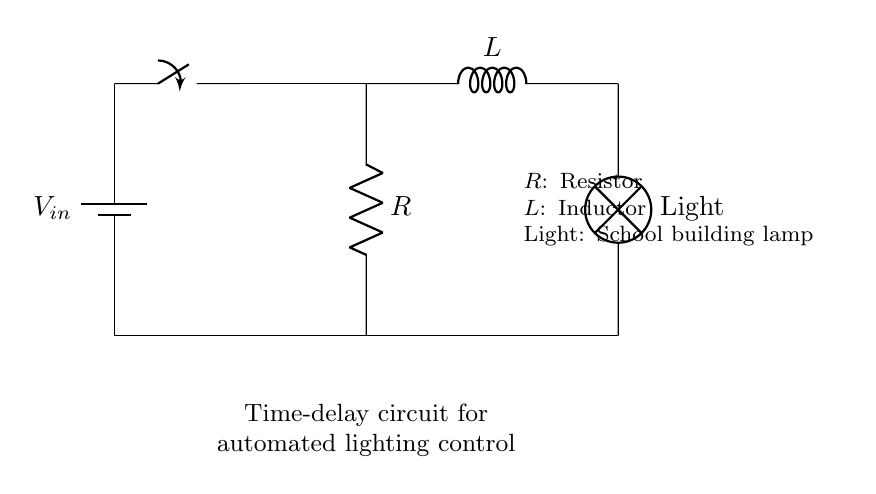What is the primary function of this circuit? The primary function of this circuit is to control the lighting automatically, by implementing a time delay before the light is turned on. This can be inferred from the circuit's designation as a time-delay circuit for automated lighting control.
Answer: Automated lighting control What are the main components used in this circuit? The main components used in this circuit are a resistor, an inductor, a light (lamp), a switch, and a battery. These components are visually identifiable in the circuit diagram.
Answer: Resistor, inductor, lamp, switch, battery What is the role of the inductor in this circuit? The inductor in this circuit helps create a delay in current flow to the lamp when the switch is closed. Because inductors resist changes in current, they store energy in the magnetic field, allowing the light to turn on after a delay instead of instantly.
Answer: Current delay How does the resistor affect the circuit's performance? The resistor limits the amount of current flowing through the circuit, which helps protect the components and can also affect the timing of the delay. A higher resistance would result in a longer time delay for the light to turn on, altering the performance of the time-delay function.
Answer: Limits current What happens when the switch is closed? When the switch is closed, current begins to flow from the battery, passing through the resistor and charging the inductor. The inductor temporarily inhibits a rapid change in current, resulting in a delayed activation of the lamp.
Answer: Delayed lamp activation What type of circuit is represented here? The type of circuit represented here is an RL (resistor-inductor) time-delay circuit. This is characterized by having both a resistor and inductor in series to create a delay effect for a connected load, such as a lamp.
Answer: RL circuit 